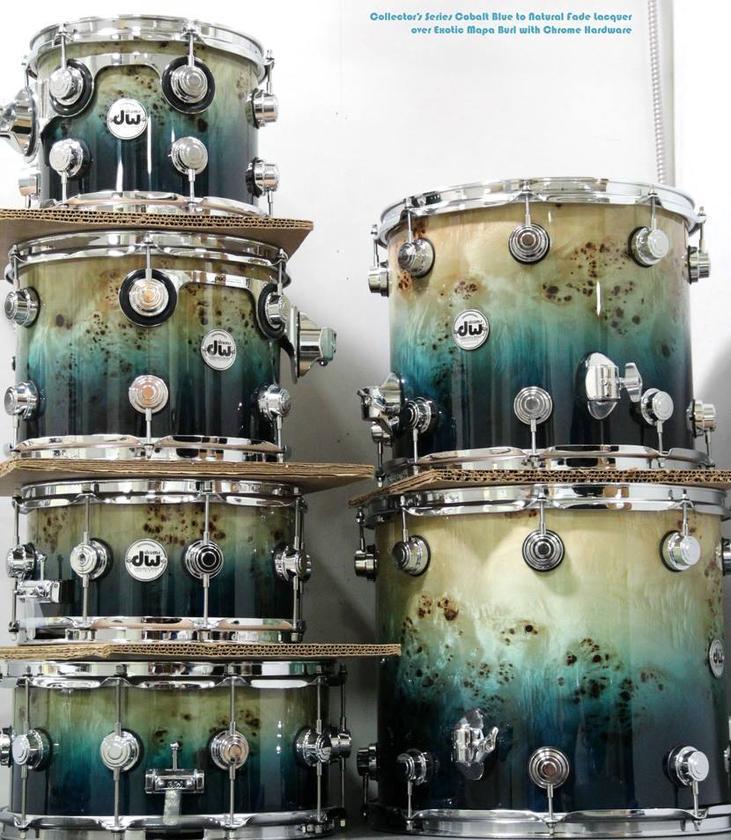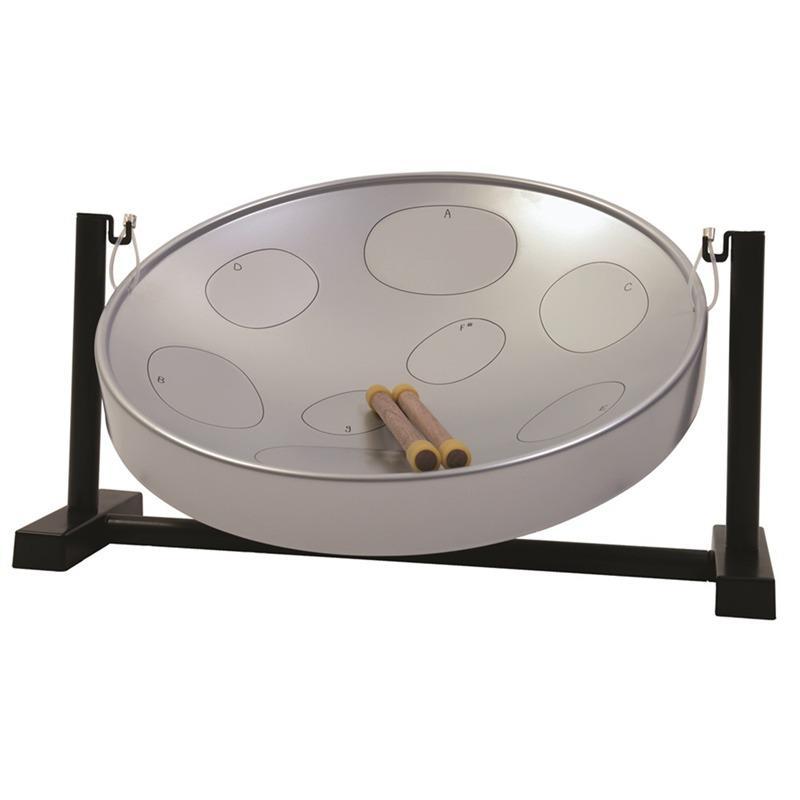The first image is the image on the left, the second image is the image on the right. Given the left and right images, does the statement "The right image features one drum with a concave top on a pivoting black stand, and the left image includes at least one cylindrical flat-topped drum displayed sitting on a flat side." hold true? Answer yes or no. Yes. The first image is the image on the left, the second image is the image on the right. Analyze the images presented: Is the assertion "There are drums stacked on top of one another." valid? Answer yes or no. Yes. 